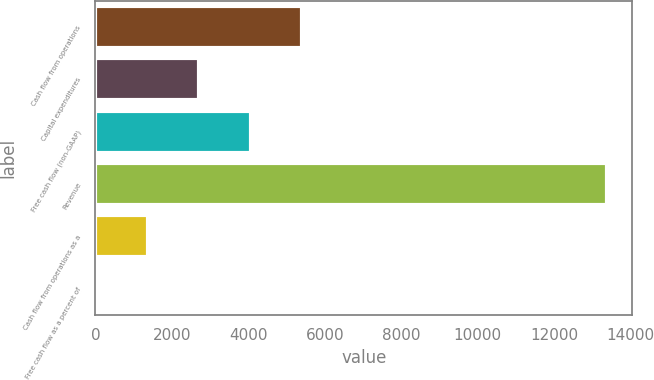<chart> <loc_0><loc_0><loc_500><loc_500><bar_chart><fcel>Cash flow from operations<fcel>Capital expenditures<fcel>Free cash flow (non-GAAP)<fcel>Revenue<fcel>Cash flow from operations as a<fcel>Free cash flow as a percent of<nl><fcel>5416.95<fcel>2698.4<fcel>4083<fcel>13370<fcel>1364.45<fcel>30.5<nl></chart> 